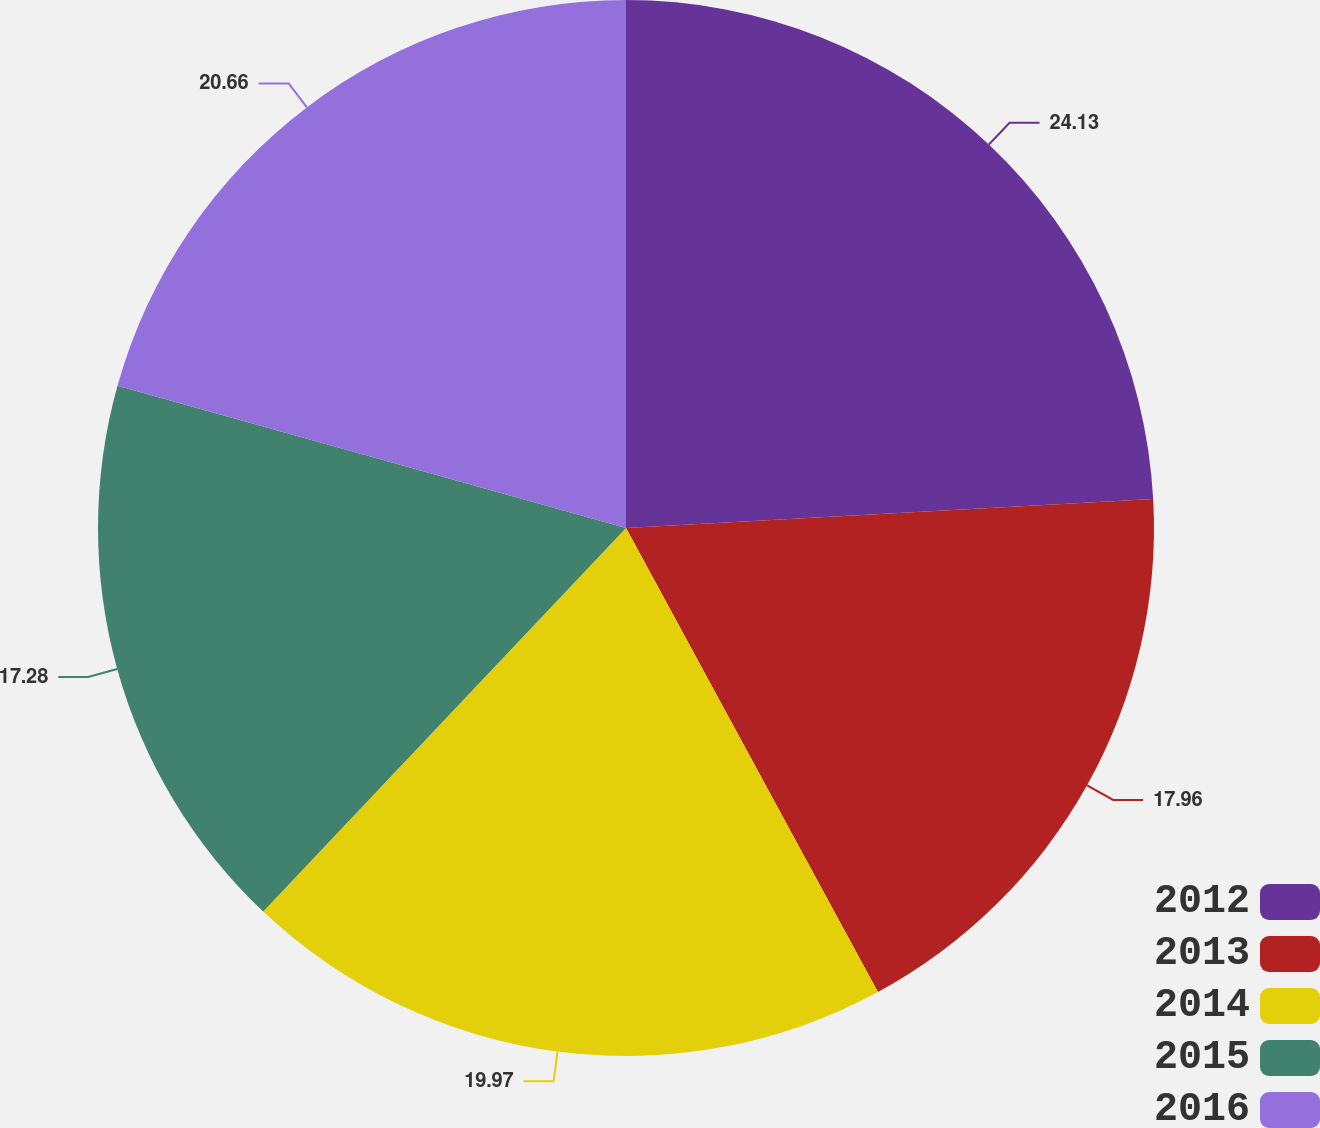Convert chart. <chart><loc_0><loc_0><loc_500><loc_500><pie_chart><fcel>2012<fcel>2013<fcel>2014<fcel>2015<fcel>2016<nl><fcel>24.12%<fcel>17.96%<fcel>19.97%<fcel>17.28%<fcel>20.66%<nl></chart> 